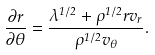<formula> <loc_0><loc_0><loc_500><loc_500>\frac { \partial r } { \partial \theta } = \frac { \lambda ^ { 1 / 2 } + \rho ^ { 1 / 2 } r v _ { r } } { \rho ^ { 1 / 2 } v _ { \theta } } .</formula> 